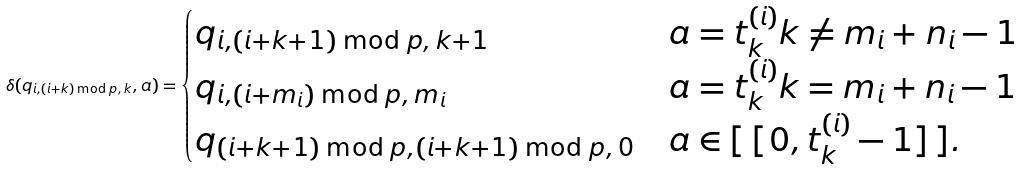<formula> <loc_0><loc_0><loc_500><loc_500>\delta ( q _ { i , ( i + k ) \bmod p , \, k } , a ) = \begin{cases} q _ { i , ( i + k + 1 ) \bmod p , \, k + 1 } & a = t _ { k } ^ { ( i ) } k \ne m _ { i } + n _ { i } - 1 \\ q _ { i , ( i + m _ { i } ) \bmod p , \, m _ { i } } & a = t _ { k } ^ { ( i ) } k = m _ { i } + n _ { i } - 1 \\ q _ { ( i + k + 1 ) \bmod p , ( i + k + 1 ) \bmod p , \, 0 } & a \in [ \, [ 0 , t _ { k } ^ { ( i ) } - 1 ] \, ] . \end{cases}</formula> 